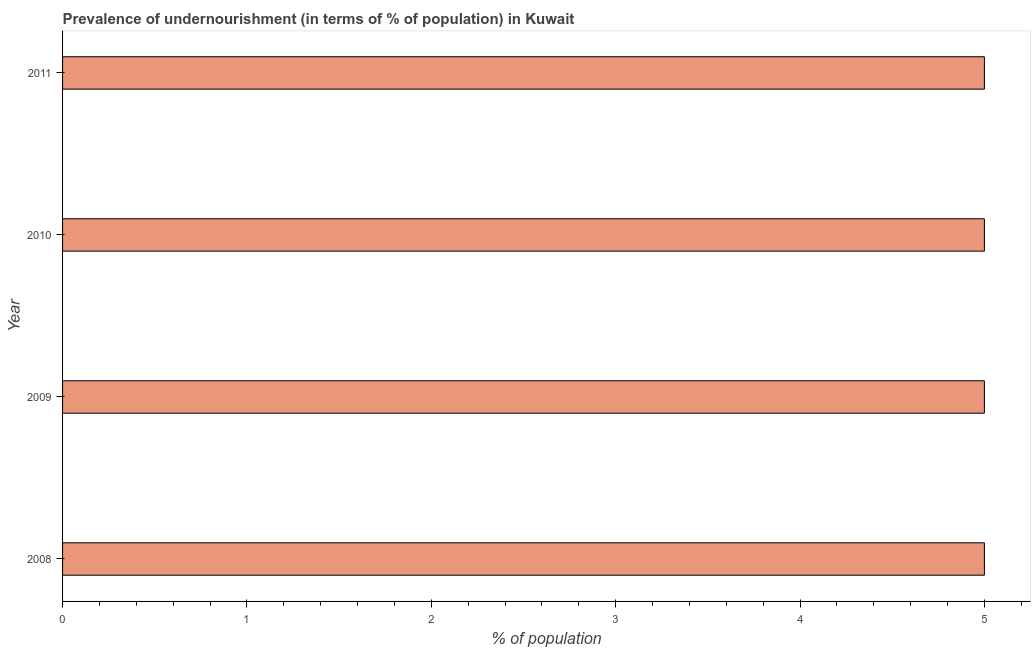What is the title of the graph?
Keep it short and to the point. Prevalence of undernourishment (in terms of % of population) in Kuwait. What is the label or title of the X-axis?
Make the answer very short. % of population. What is the label or title of the Y-axis?
Offer a very short reply. Year. Across all years, what is the maximum percentage of undernourished population?
Give a very brief answer. 5. In which year was the percentage of undernourished population minimum?
Offer a very short reply. 2008. What is the median percentage of undernourished population?
Your answer should be very brief. 5. In how many years, is the percentage of undernourished population greater than 0.6 %?
Offer a very short reply. 4. Do a majority of the years between 2008 and 2011 (inclusive) have percentage of undernourished population greater than 3.8 %?
Your answer should be compact. Yes. What is the difference between the highest and the second highest percentage of undernourished population?
Your response must be concise. 0. Is the sum of the percentage of undernourished population in 2009 and 2011 greater than the maximum percentage of undernourished population across all years?
Provide a succinct answer. Yes. Are all the bars in the graph horizontal?
Your answer should be very brief. Yes. What is the difference between two consecutive major ticks on the X-axis?
Offer a terse response. 1. What is the % of population of 2010?
Offer a very short reply. 5. What is the % of population of 2011?
Your response must be concise. 5. What is the difference between the % of population in 2008 and 2009?
Give a very brief answer. 0. What is the difference between the % of population in 2009 and 2010?
Offer a terse response. 0. What is the difference between the % of population in 2009 and 2011?
Offer a very short reply. 0. What is the ratio of the % of population in 2008 to that in 2009?
Provide a short and direct response. 1. What is the ratio of the % of population in 2008 to that in 2011?
Give a very brief answer. 1. What is the ratio of the % of population in 2009 to that in 2010?
Ensure brevity in your answer.  1. What is the ratio of the % of population in 2009 to that in 2011?
Your answer should be very brief. 1. 